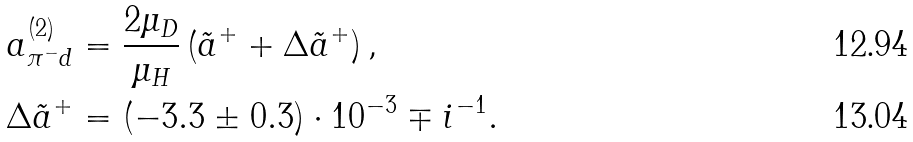Convert formula to latex. <formula><loc_0><loc_0><loc_500><loc_500>a _ { \pi ^ { - } d } ^ { ( 2 ) } & = \frac { 2 \mu _ { D } } { \mu _ { H } } \left ( \tilde { a } ^ { + } + \Delta \tilde { a } ^ { + } \right ) , \\ \Delta \tilde { a } ^ { + } & = ( - 3 . 3 \pm 0 . 3 ) \cdot 1 0 ^ { - 3 } \mp i ^ { - 1 } .</formula> 